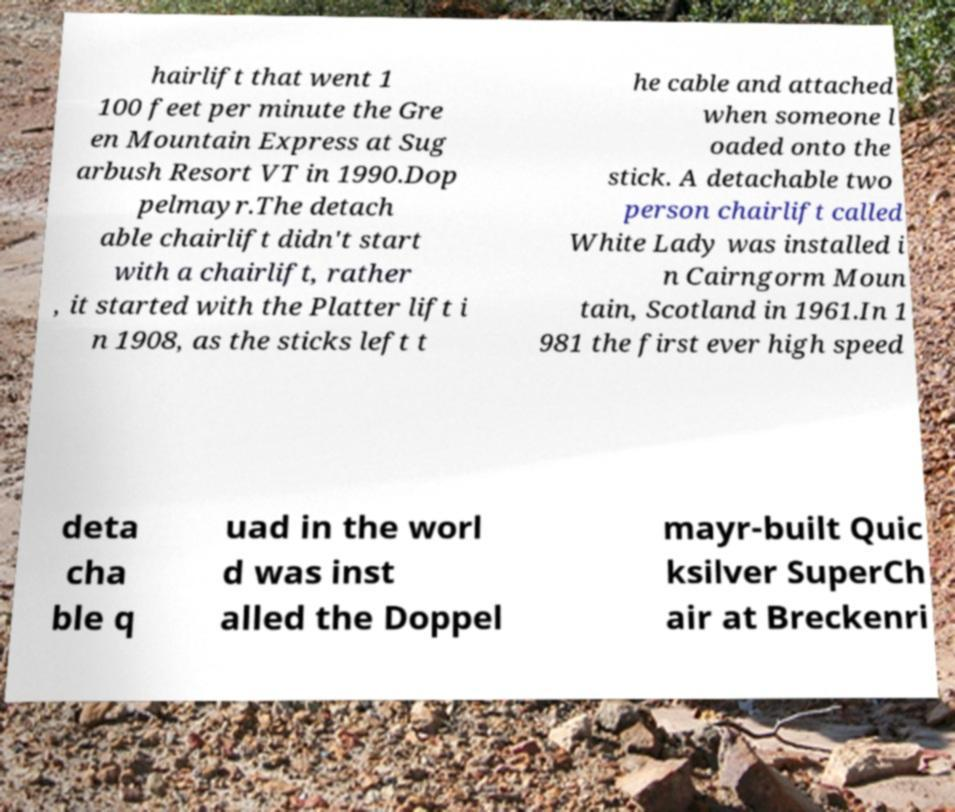For documentation purposes, I need the text within this image transcribed. Could you provide that? hairlift that went 1 100 feet per minute the Gre en Mountain Express at Sug arbush Resort VT in 1990.Dop pelmayr.The detach able chairlift didn't start with a chairlift, rather , it started with the Platter lift i n 1908, as the sticks left t he cable and attached when someone l oaded onto the stick. A detachable two person chairlift called White Lady was installed i n Cairngorm Moun tain, Scotland in 1961.In 1 981 the first ever high speed deta cha ble q uad in the worl d was inst alled the Doppel mayr-built Quic ksilver SuperCh air at Breckenri 